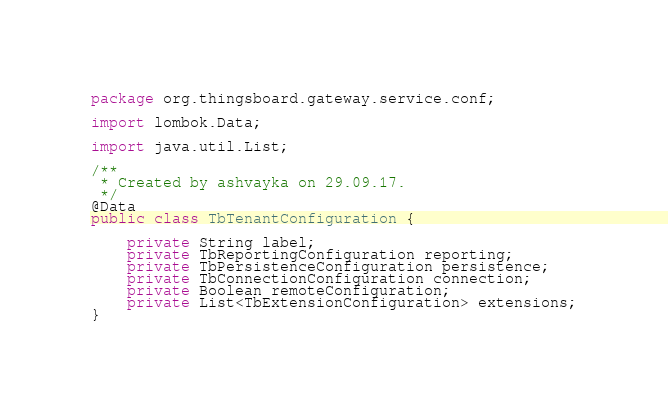Convert code to text. <code><loc_0><loc_0><loc_500><loc_500><_Java_>package org.thingsboard.gateway.service.conf;

import lombok.Data;

import java.util.List;

/**
 * Created by ashvayka on 29.09.17.
 */
@Data
public class TbTenantConfiguration {

    private String label;
    private TbReportingConfiguration reporting;
    private TbPersistenceConfiguration persistence;
    private TbConnectionConfiguration connection;
    private Boolean remoteConfiguration;
    private List<TbExtensionConfiguration> extensions;
}
</code> 